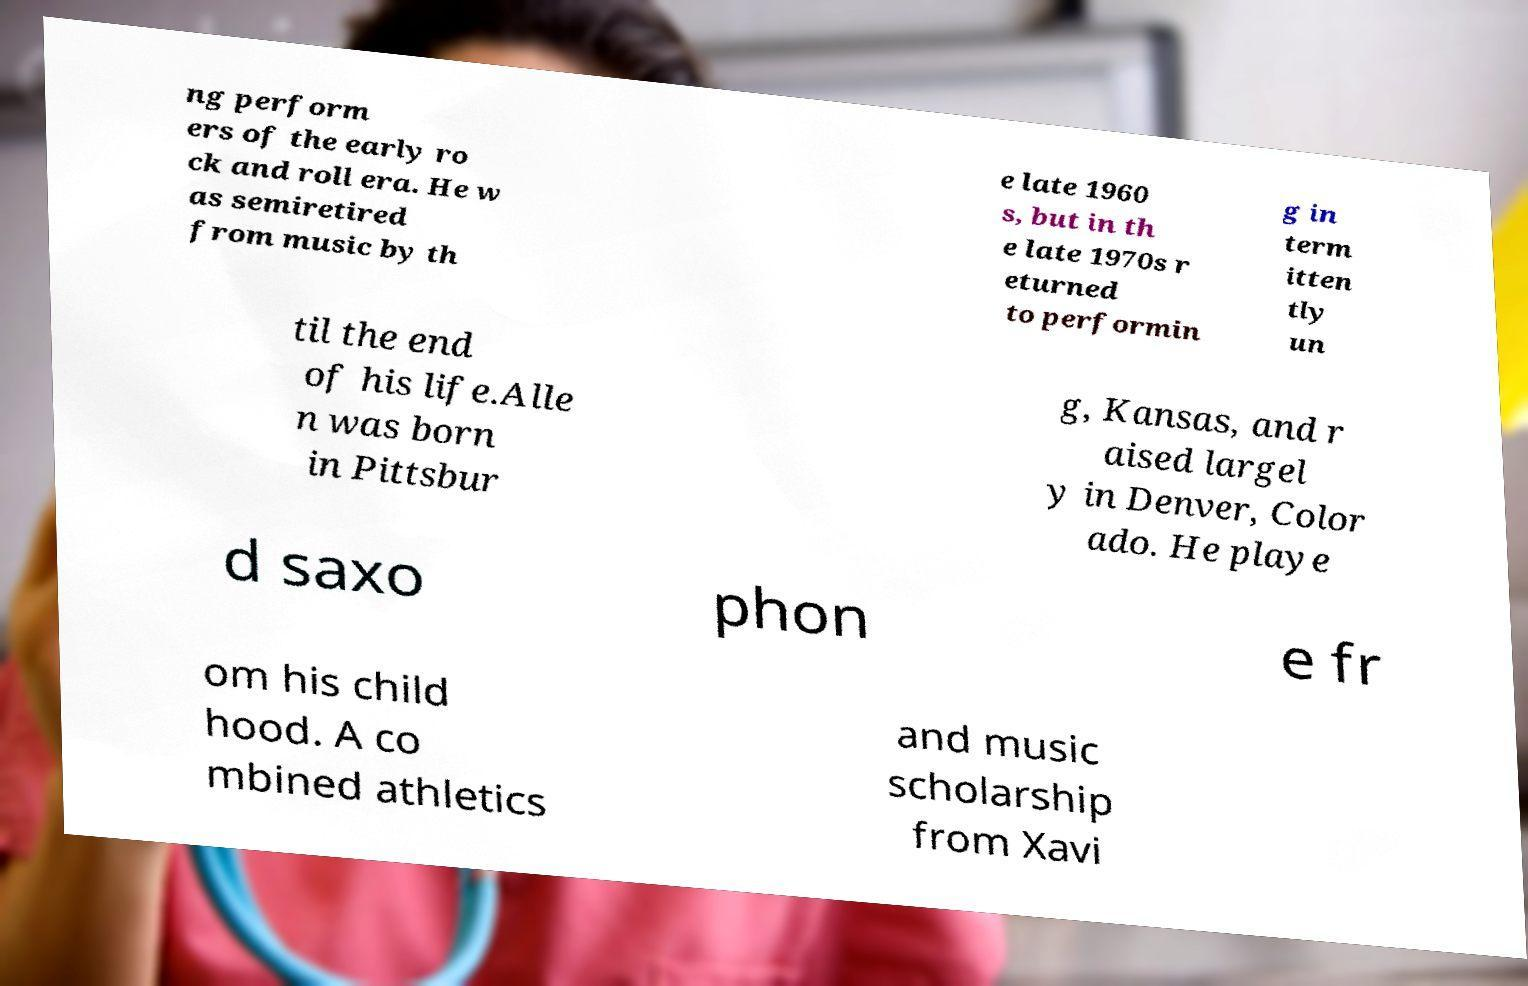Can you accurately transcribe the text from the provided image for me? ng perform ers of the early ro ck and roll era. He w as semiretired from music by th e late 1960 s, but in th e late 1970s r eturned to performin g in term itten tly un til the end of his life.Alle n was born in Pittsbur g, Kansas, and r aised largel y in Denver, Color ado. He playe d saxo phon e fr om his child hood. A co mbined athletics and music scholarship from Xavi 